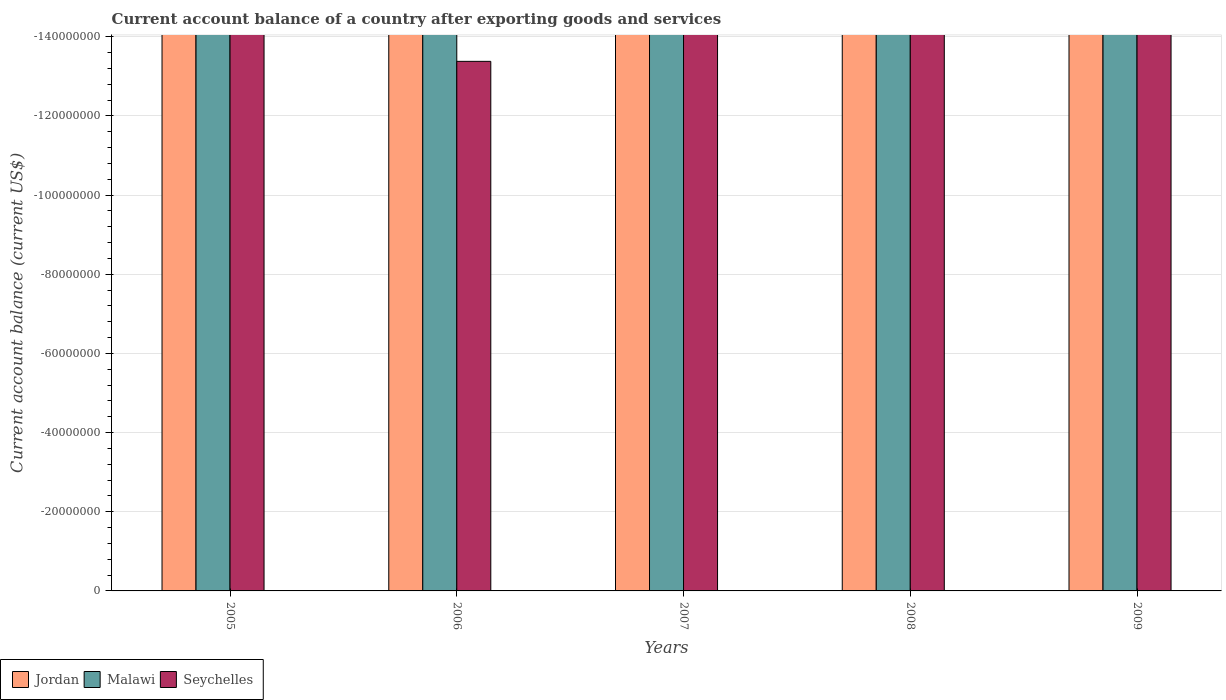How many bars are there on the 5th tick from the right?
Keep it short and to the point. 0. What is the label of the 4th group of bars from the left?
Provide a short and direct response. 2008. In how many cases, is the number of bars for a given year not equal to the number of legend labels?
Keep it short and to the point. 5. Are all the bars in the graph horizontal?
Your answer should be very brief. No. Are the values on the major ticks of Y-axis written in scientific E-notation?
Offer a terse response. No. Does the graph contain grids?
Offer a very short reply. Yes. Where does the legend appear in the graph?
Give a very brief answer. Bottom left. What is the title of the graph?
Give a very brief answer. Current account balance of a country after exporting goods and services. Does "Togo" appear as one of the legend labels in the graph?
Give a very brief answer. No. What is the label or title of the Y-axis?
Your response must be concise. Current account balance (current US$). What is the Current account balance (current US$) in Jordan in 2005?
Offer a terse response. 0. What is the Current account balance (current US$) in Seychelles in 2005?
Ensure brevity in your answer.  0. What is the Current account balance (current US$) of Jordan in 2007?
Offer a terse response. 0. What is the Current account balance (current US$) in Malawi in 2007?
Keep it short and to the point. 0. What is the Current account balance (current US$) of Jordan in 2008?
Your answer should be compact. 0. What is the Current account balance (current US$) of Malawi in 2008?
Offer a very short reply. 0. What is the Current account balance (current US$) in Jordan in 2009?
Your answer should be very brief. 0. What is the Current account balance (current US$) in Seychelles in 2009?
Provide a short and direct response. 0. What is the average Current account balance (current US$) of Seychelles per year?
Offer a very short reply. 0. 